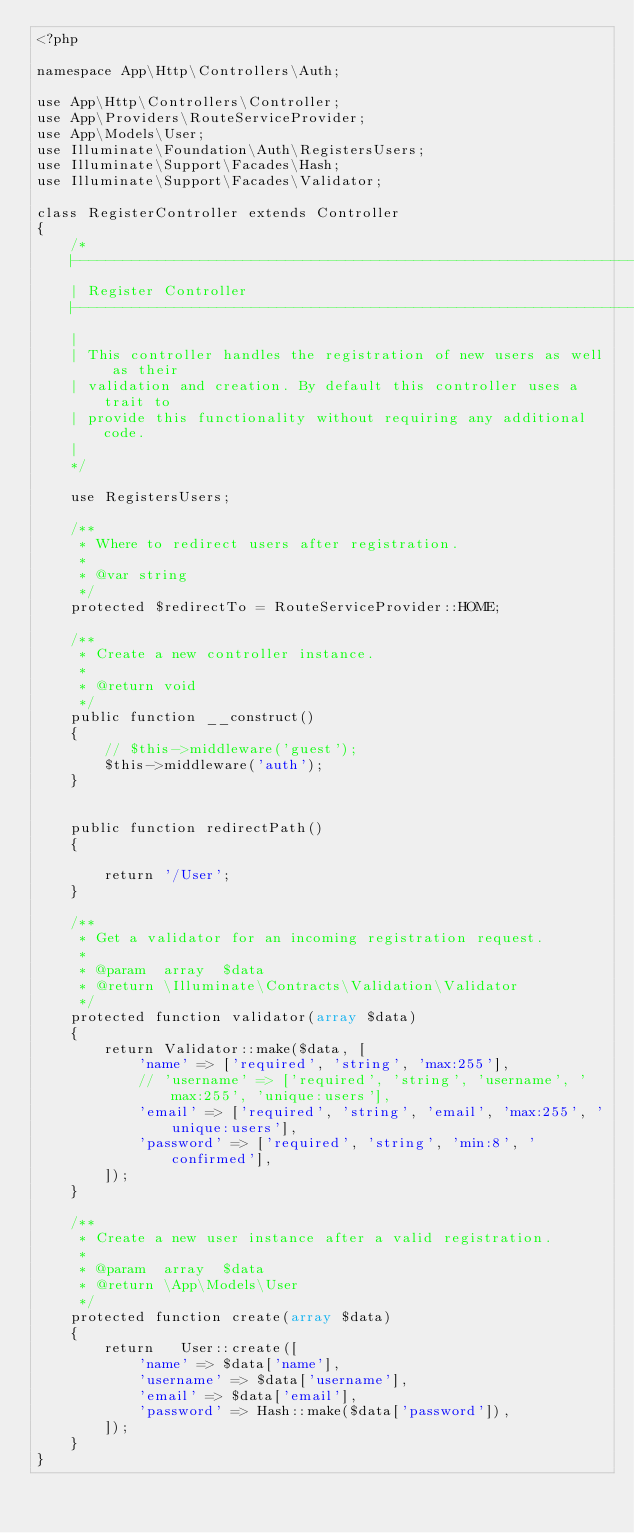<code> <loc_0><loc_0><loc_500><loc_500><_PHP_><?php

namespace App\Http\Controllers\Auth;

use App\Http\Controllers\Controller;
use App\Providers\RouteServiceProvider;
use App\Models\User;
use Illuminate\Foundation\Auth\RegistersUsers;
use Illuminate\Support\Facades\Hash;
use Illuminate\Support\Facades\Validator;

class RegisterController extends Controller
{
    /*
    |--------------------------------------------------------------------------
    | Register Controller
    |--------------------------------------------------------------------------
    |
    | This controller handles the registration of new users as well as their
    | validation and creation. By default this controller uses a trait to
    | provide this functionality without requiring any additional code.
    |
    */

    use RegistersUsers;

    /**
     * Where to redirect users after registration.
     *
     * @var string
     */
    protected $redirectTo = RouteServiceProvider::HOME;

    /**
     * Create a new controller instance.
     *
     * @return void
     */
    public function __construct()
    {
        // $this->middleware('guest');
        $this->middleware('auth');
    }


    public function redirectPath()
    {

        return '/User';
    }

    /**
     * Get a validator for an incoming registration request.
     *
     * @param  array  $data
     * @return \Illuminate\Contracts\Validation\Validator
     */
    protected function validator(array $data)
    {
        return Validator::make($data, [
            'name' => ['required', 'string', 'max:255'],
            // 'username' => ['required', 'string', 'username', 'max:255', 'unique:users'],
            'email' => ['required', 'string', 'email', 'max:255', 'unique:users'],
            'password' => ['required', 'string', 'min:8', 'confirmed'],
        ]);
    }

    /**
     * Create a new user instance after a valid registration.
     *
     * @param  array  $data
     * @return \App\Models\User
     */
    protected function create(array $data)
    {
        return   User::create([
            'name' => $data['name'],
            'username' => $data['username'],
            'email' => $data['email'],
            'password' => Hash::make($data['password']),
        ]);
    }
}
</code> 